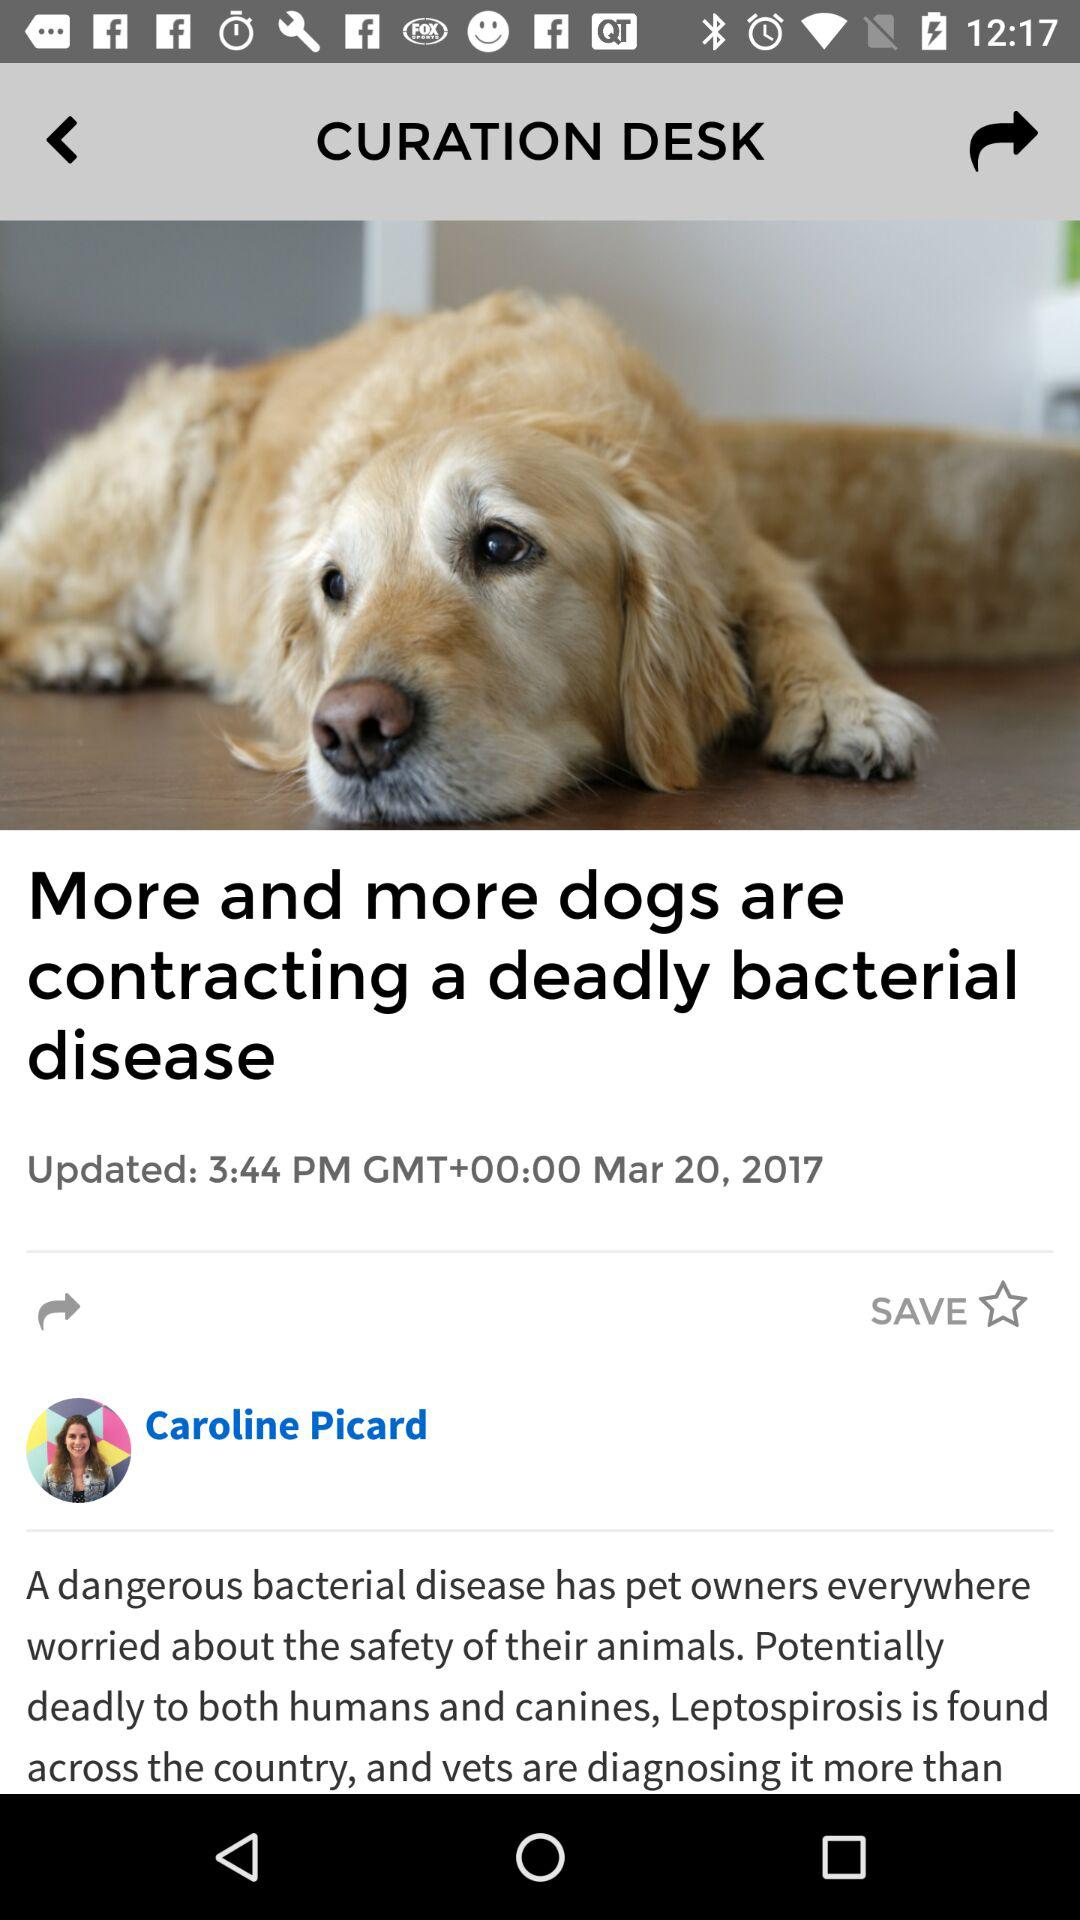What is the headline of the article? The headline is "More and more dogs are contracting a deadly bacterial disease". 